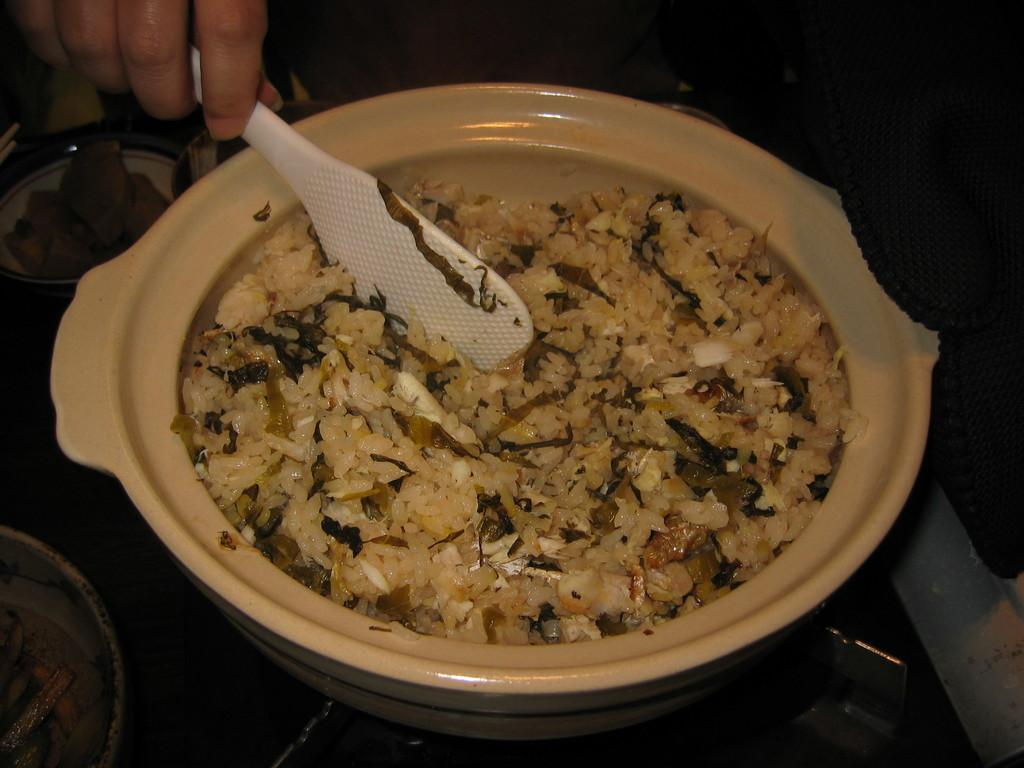What is in the bowl that is visible in the image? There is a bowl with food in the image. Who is holding a white spoon in the image? There is a person holding a white spoon in the image. How is the person holding the spoon? The person is holding the spoon in their hand. Where is the bowl with food located? The bowl is on the stove. What can be seen in the background of the image? There are bowls with food items in the background of the image. What type of engine is visible in the image? There is no engine present in the image. What type of skirt is the person wearing in the image? The image does not show the person's clothing, so it cannot be determined if they are wearing a skirt. 